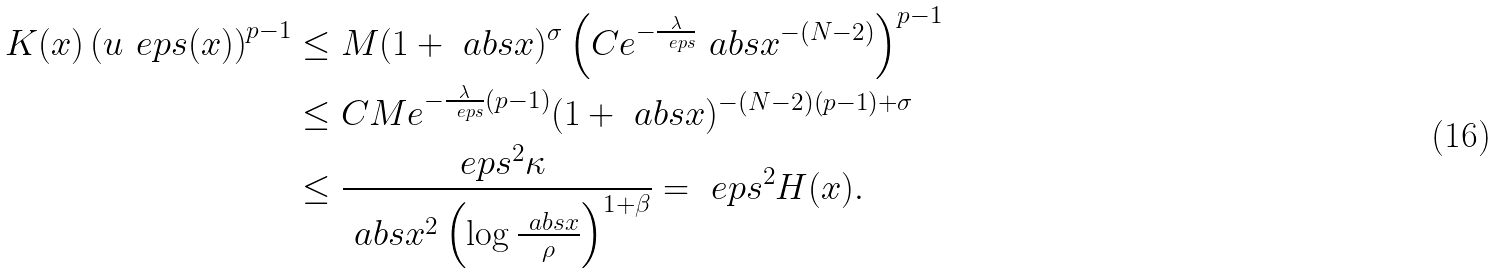Convert formula to latex. <formula><loc_0><loc_0><loc_500><loc_500>K ( x ) \left ( u _ { \ } e p s ( x ) \right ) ^ { p - 1 } & \leq M ( 1 + \ a b s { x } ) ^ { \sigma } \left ( C e ^ { - \frac { \lambda } { \ e p s } } \ a b s { x } ^ { - ( N - 2 ) } \right ) ^ { p - 1 } \\ & \leq C M e ^ { - \frac { \lambda } { \ e p s } ( p - 1 ) } ( 1 + \ a b s { x } ) ^ { - ( N - 2 ) ( p - 1 ) + \sigma } \\ & \leq \frac { \ e p s ^ { 2 } \kappa } { \ a b s { x } ^ { 2 } \left ( \log \frac { \ a b s { x } } { \rho } \right ) ^ { 1 + \beta } } = \ e p s ^ { 2 } H ( x ) .</formula> 